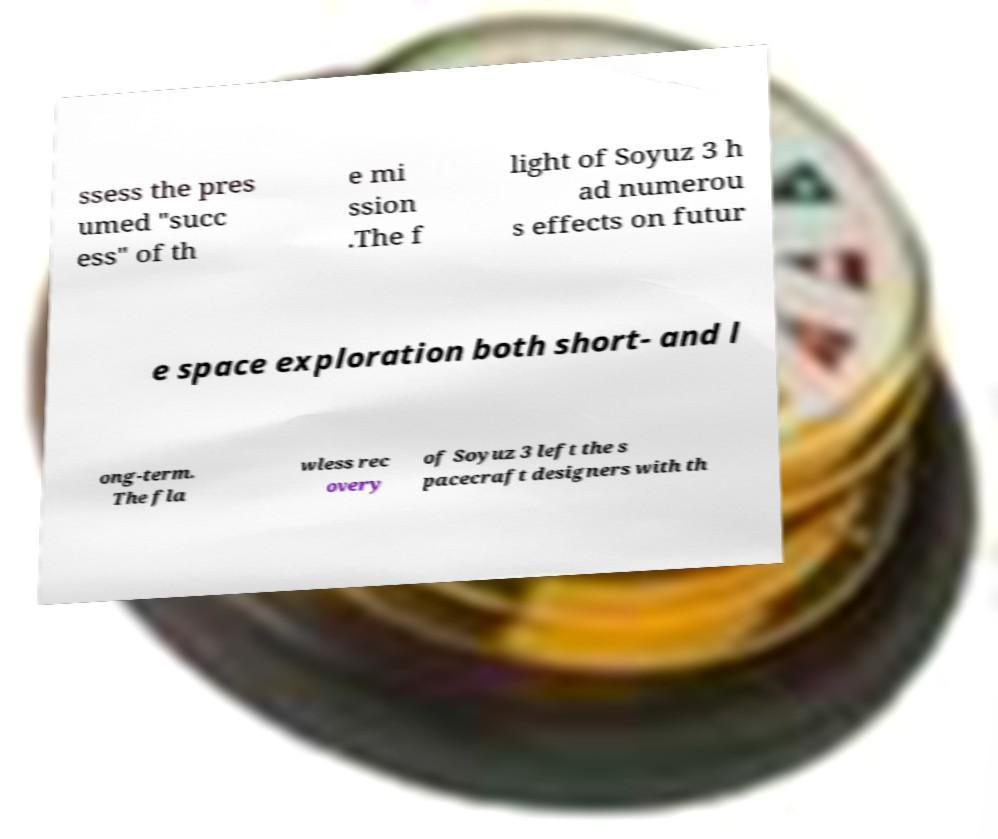Please identify and transcribe the text found in this image. ssess the pres umed "succ ess" of th e mi ssion .The f light of Soyuz 3 h ad numerou s effects on futur e space exploration both short- and l ong-term. The fla wless rec overy of Soyuz 3 left the s pacecraft designers with th 